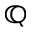Convert formula to latex. <formula><loc_0><loc_0><loc_500><loc_500>\mathbb { Q }</formula> 